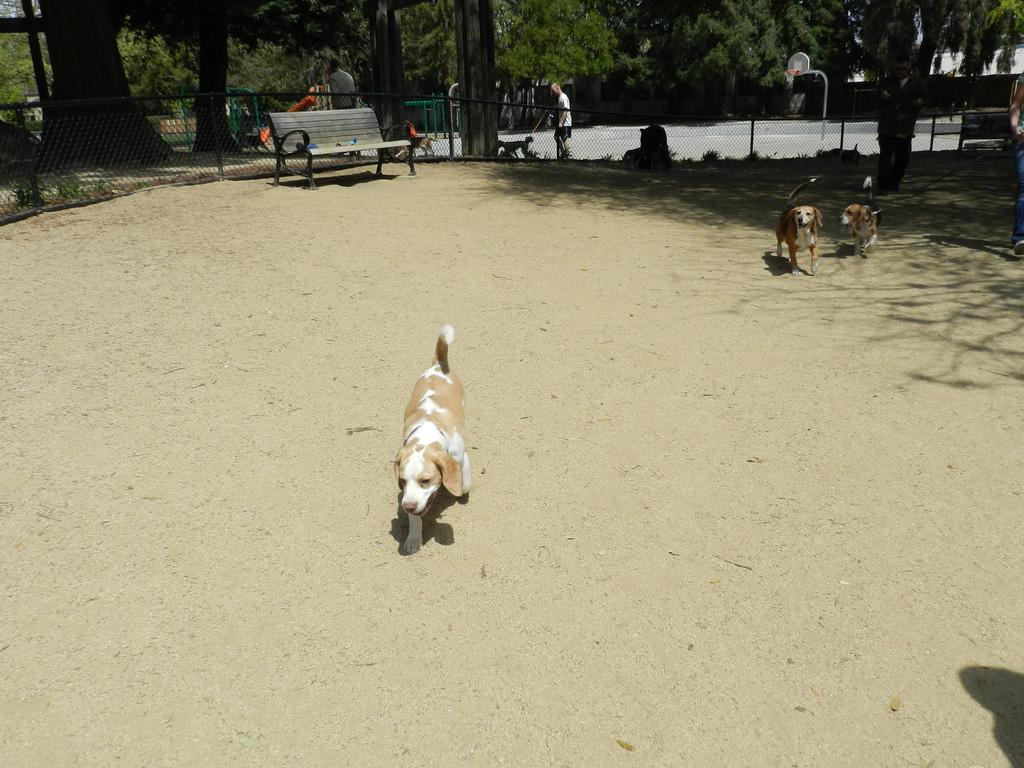What type of location is depicted in the image? There is a park in the image. What animals can be seen in the park? There are dogs in the park. What type of seating is available in the park? There is a bench in the park. What can be seen in the background of the image? There are trees in the background of the image. What type of structure is being attempted by the dogs in the image? There is no indication in the image that the dogs are attempting to build or interact with any structure. 